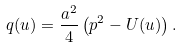Convert formula to latex. <formula><loc_0><loc_0><loc_500><loc_500>q ( u ) = \frac { a ^ { 2 } } { 4 } \left ( p ^ { 2 } - U ( u ) \right ) .</formula> 